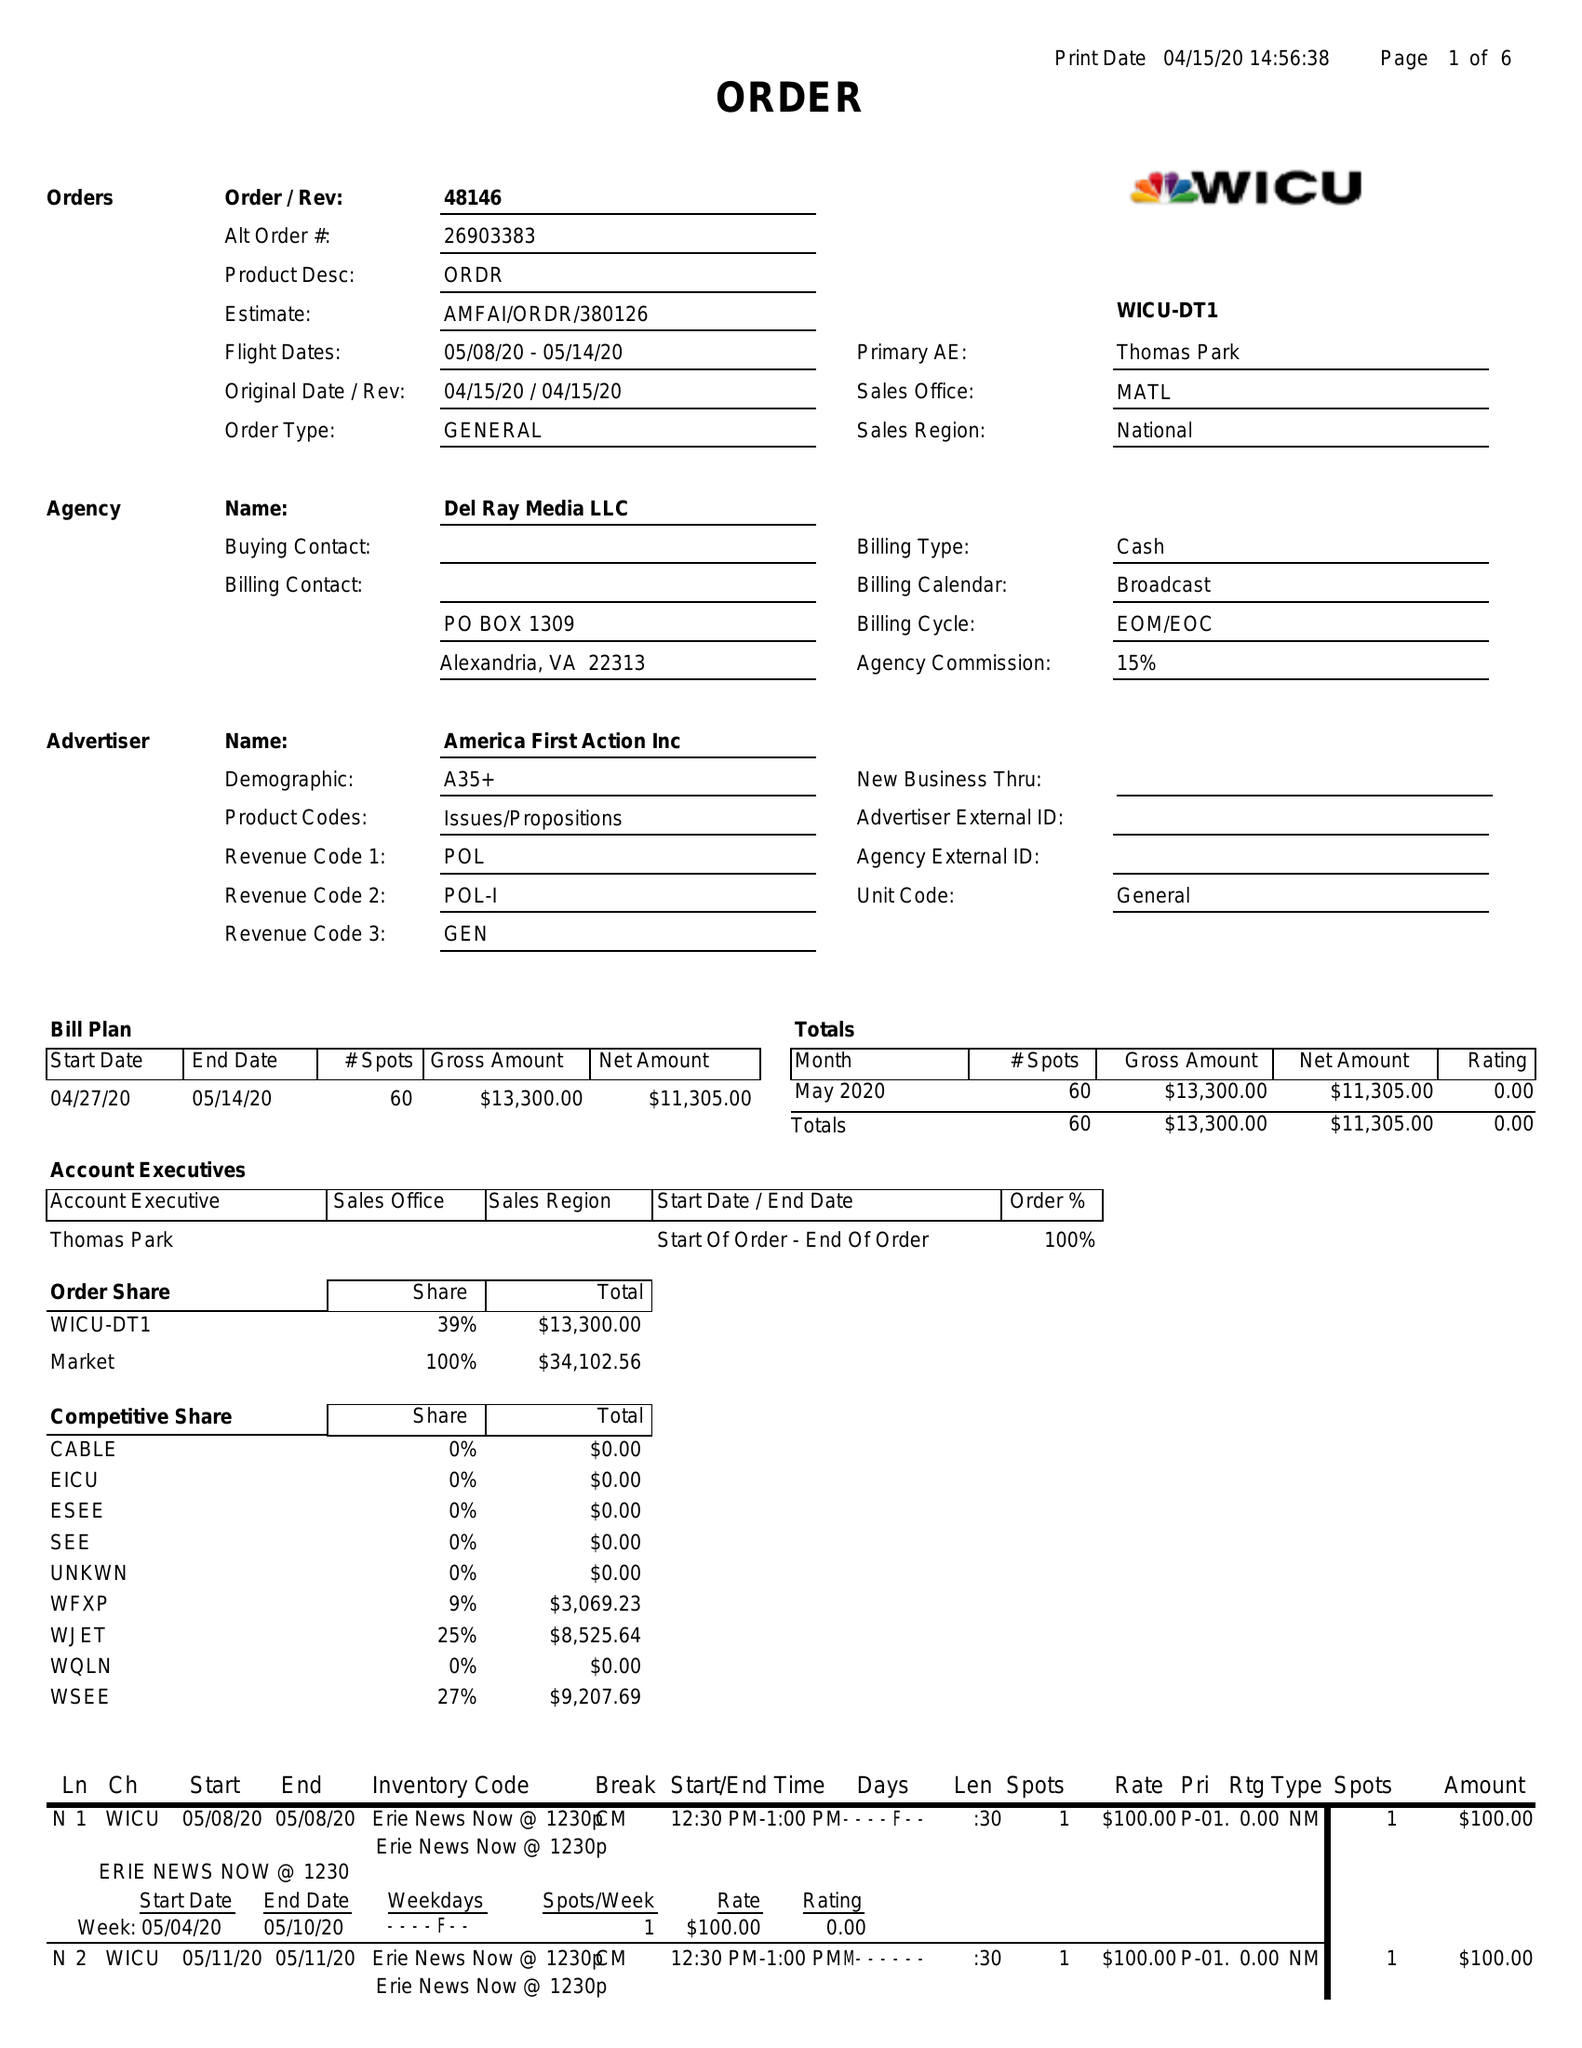What is the value for the contract_num?
Answer the question using a single word or phrase. 48146 